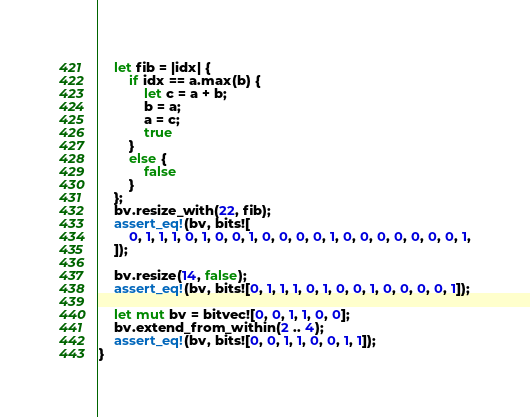Convert code to text. <code><loc_0><loc_0><loc_500><loc_500><_Rust_>	let fib = |idx| {
		if idx == a.max(b) {
			let c = a + b;
			b = a;
			a = c;
			true
		}
		else {
			false
		}
	};
	bv.resize_with(22, fib);
	assert_eq!(bv, bits![
		0, 1, 1, 1, 0, 1, 0, 0, 1, 0, 0, 0, 0, 1, 0, 0, 0, 0, 0, 0, 0, 1,
	]);

	bv.resize(14, false);
	assert_eq!(bv, bits![0, 1, 1, 1, 0, 1, 0, 0, 1, 0, 0, 0, 0, 1]);

	let mut bv = bitvec![0, 0, 1, 1, 0, 0];
	bv.extend_from_within(2 .. 4);
	assert_eq!(bv, bits![0, 0, 1, 1, 0, 0, 1, 1]);
}
</code> 